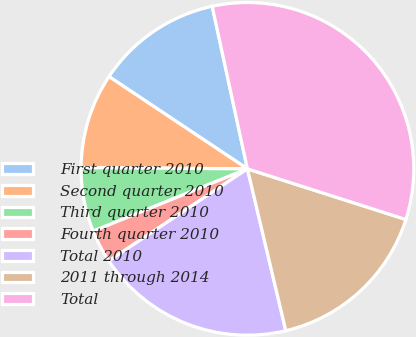<chart> <loc_0><loc_0><loc_500><loc_500><pie_chart><fcel>First quarter 2010<fcel>Second quarter 2010<fcel>Third quarter 2010<fcel>Fourth quarter 2010<fcel>Total 2010<fcel>2011 through 2014<fcel>Total<nl><fcel>12.25%<fcel>9.24%<fcel>6.23%<fcel>3.22%<fcel>19.38%<fcel>16.37%<fcel>33.32%<nl></chart> 